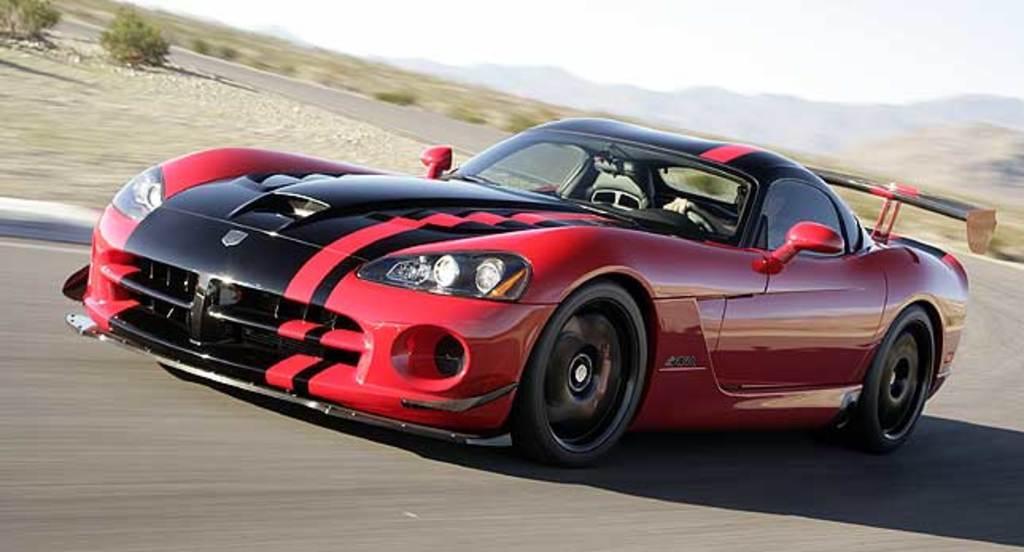In one or two sentences, can you explain what this image depicts? In this picture there is a car moving on the road with the person sitting inside it. In the background there are mountains, plants. 